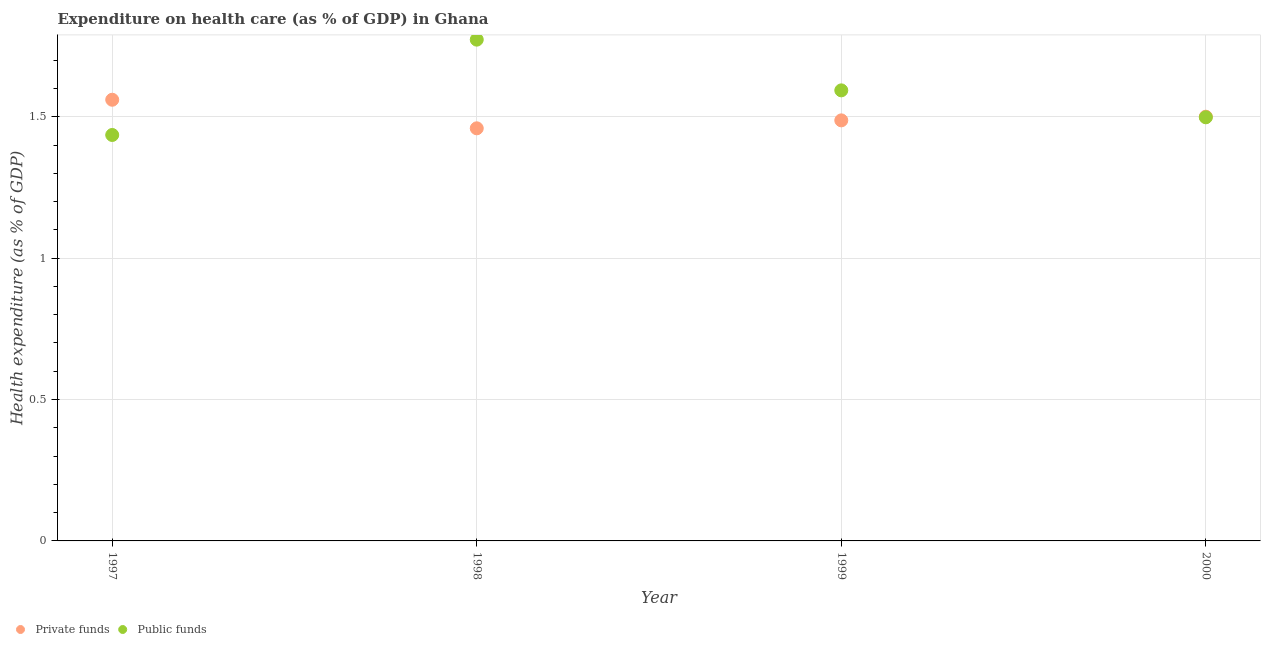What is the amount of private funds spent in healthcare in 2000?
Your answer should be very brief. 1.5. Across all years, what is the maximum amount of public funds spent in healthcare?
Provide a short and direct response. 1.77. Across all years, what is the minimum amount of public funds spent in healthcare?
Your response must be concise. 1.44. In which year was the amount of public funds spent in healthcare maximum?
Your answer should be compact. 1998. In which year was the amount of private funds spent in healthcare minimum?
Your response must be concise. 1998. What is the total amount of public funds spent in healthcare in the graph?
Provide a succinct answer. 6.3. What is the difference between the amount of public funds spent in healthcare in 1997 and that in 1999?
Give a very brief answer. -0.16. What is the difference between the amount of private funds spent in healthcare in 1998 and the amount of public funds spent in healthcare in 2000?
Offer a terse response. -0.04. What is the average amount of private funds spent in healthcare per year?
Offer a very short reply. 1.5. In the year 1998, what is the difference between the amount of private funds spent in healthcare and amount of public funds spent in healthcare?
Keep it short and to the point. -0.31. In how many years, is the amount of public funds spent in healthcare greater than 1.5 %?
Your response must be concise. 2. What is the ratio of the amount of public funds spent in healthcare in 1997 to that in 2000?
Make the answer very short. 0.96. What is the difference between the highest and the second highest amount of private funds spent in healthcare?
Offer a terse response. 0.06. What is the difference between the highest and the lowest amount of private funds spent in healthcare?
Your answer should be compact. 0.1. Is the sum of the amount of public funds spent in healthcare in 1997 and 2000 greater than the maximum amount of private funds spent in healthcare across all years?
Keep it short and to the point. Yes. Does the amount of public funds spent in healthcare monotonically increase over the years?
Make the answer very short. No. Is the amount of private funds spent in healthcare strictly greater than the amount of public funds spent in healthcare over the years?
Your answer should be compact. No. How many dotlines are there?
Ensure brevity in your answer.  2. How many years are there in the graph?
Your answer should be compact. 4. Where does the legend appear in the graph?
Offer a terse response. Bottom left. How are the legend labels stacked?
Offer a terse response. Horizontal. What is the title of the graph?
Keep it short and to the point. Expenditure on health care (as % of GDP) in Ghana. Does "Working only" appear as one of the legend labels in the graph?
Your response must be concise. No. What is the label or title of the X-axis?
Keep it short and to the point. Year. What is the label or title of the Y-axis?
Make the answer very short. Health expenditure (as % of GDP). What is the Health expenditure (as % of GDP) of Private funds in 1997?
Your answer should be very brief. 1.56. What is the Health expenditure (as % of GDP) in Public funds in 1997?
Ensure brevity in your answer.  1.44. What is the Health expenditure (as % of GDP) of Private funds in 1998?
Provide a short and direct response. 1.46. What is the Health expenditure (as % of GDP) of Public funds in 1998?
Your response must be concise. 1.77. What is the Health expenditure (as % of GDP) of Private funds in 1999?
Offer a very short reply. 1.49. What is the Health expenditure (as % of GDP) of Public funds in 1999?
Offer a terse response. 1.59. What is the Health expenditure (as % of GDP) of Private funds in 2000?
Offer a terse response. 1.5. What is the Health expenditure (as % of GDP) of Public funds in 2000?
Offer a terse response. 1.5. Across all years, what is the maximum Health expenditure (as % of GDP) in Private funds?
Provide a short and direct response. 1.56. Across all years, what is the maximum Health expenditure (as % of GDP) of Public funds?
Make the answer very short. 1.77. Across all years, what is the minimum Health expenditure (as % of GDP) in Private funds?
Keep it short and to the point. 1.46. Across all years, what is the minimum Health expenditure (as % of GDP) of Public funds?
Offer a terse response. 1.44. What is the total Health expenditure (as % of GDP) in Private funds in the graph?
Make the answer very short. 6.01. What is the total Health expenditure (as % of GDP) in Public funds in the graph?
Ensure brevity in your answer.  6.3. What is the difference between the Health expenditure (as % of GDP) in Private funds in 1997 and that in 1998?
Provide a short and direct response. 0.1. What is the difference between the Health expenditure (as % of GDP) in Public funds in 1997 and that in 1998?
Offer a terse response. -0.34. What is the difference between the Health expenditure (as % of GDP) in Private funds in 1997 and that in 1999?
Offer a terse response. 0.07. What is the difference between the Health expenditure (as % of GDP) of Public funds in 1997 and that in 1999?
Offer a very short reply. -0.16. What is the difference between the Health expenditure (as % of GDP) of Private funds in 1997 and that in 2000?
Keep it short and to the point. 0.06. What is the difference between the Health expenditure (as % of GDP) in Public funds in 1997 and that in 2000?
Provide a succinct answer. -0.06. What is the difference between the Health expenditure (as % of GDP) of Private funds in 1998 and that in 1999?
Your response must be concise. -0.03. What is the difference between the Health expenditure (as % of GDP) of Public funds in 1998 and that in 1999?
Your response must be concise. 0.18. What is the difference between the Health expenditure (as % of GDP) in Private funds in 1998 and that in 2000?
Make the answer very short. -0.04. What is the difference between the Health expenditure (as % of GDP) of Public funds in 1998 and that in 2000?
Offer a terse response. 0.27. What is the difference between the Health expenditure (as % of GDP) in Private funds in 1999 and that in 2000?
Offer a terse response. -0.01. What is the difference between the Health expenditure (as % of GDP) of Public funds in 1999 and that in 2000?
Your response must be concise. 0.1. What is the difference between the Health expenditure (as % of GDP) of Private funds in 1997 and the Health expenditure (as % of GDP) of Public funds in 1998?
Make the answer very short. -0.21. What is the difference between the Health expenditure (as % of GDP) in Private funds in 1997 and the Health expenditure (as % of GDP) in Public funds in 1999?
Ensure brevity in your answer.  -0.03. What is the difference between the Health expenditure (as % of GDP) in Private funds in 1997 and the Health expenditure (as % of GDP) in Public funds in 2000?
Give a very brief answer. 0.06. What is the difference between the Health expenditure (as % of GDP) of Private funds in 1998 and the Health expenditure (as % of GDP) of Public funds in 1999?
Provide a short and direct response. -0.13. What is the difference between the Health expenditure (as % of GDP) in Private funds in 1998 and the Health expenditure (as % of GDP) in Public funds in 2000?
Ensure brevity in your answer.  -0.04. What is the difference between the Health expenditure (as % of GDP) in Private funds in 1999 and the Health expenditure (as % of GDP) in Public funds in 2000?
Provide a short and direct response. -0.01. What is the average Health expenditure (as % of GDP) in Private funds per year?
Keep it short and to the point. 1.5. What is the average Health expenditure (as % of GDP) in Public funds per year?
Your answer should be compact. 1.57. In the year 1997, what is the difference between the Health expenditure (as % of GDP) of Private funds and Health expenditure (as % of GDP) of Public funds?
Your response must be concise. 0.12. In the year 1998, what is the difference between the Health expenditure (as % of GDP) in Private funds and Health expenditure (as % of GDP) in Public funds?
Offer a very short reply. -0.31. In the year 1999, what is the difference between the Health expenditure (as % of GDP) of Private funds and Health expenditure (as % of GDP) of Public funds?
Ensure brevity in your answer.  -0.11. In the year 2000, what is the difference between the Health expenditure (as % of GDP) in Private funds and Health expenditure (as % of GDP) in Public funds?
Keep it short and to the point. 0. What is the ratio of the Health expenditure (as % of GDP) of Private funds in 1997 to that in 1998?
Keep it short and to the point. 1.07. What is the ratio of the Health expenditure (as % of GDP) in Public funds in 1997 to that in 1998?
Your answer should be compact. 0.81. What is the ratio of the Health expenditure (as % of GDP) in Private funds in 1997 to that in 1999?
Offer a terse response. 1.05. What is the ratio of the Health expenditure (as % of GDP) of Public funds in 1997 to that in 1999?
Give a very brief answer. 0.9. What is the ratio of the Health expenditure (as % of GDP) of Private funds in 1997 to that in 2000?
Provide a succinct answer. 1.04. What is the ratio of the Health expenditure (as % of GDP) of Private funds in 1998 to that in 1999?
Keep it short and to the point. 0.98. What is the ratio of the Health expenditure (as % of GDP) in Public funds in 1998 to that in 1999?
Your answer should be very brief. 1.11. What is the ratio of the Health expenditure (as % of GDP) of Private funds in 1998 to that in 2000?
Offer a very short reply. 0.97. What is the ratio of the Health expenditure (as % of GDP) of Public funds in 1998 to that in 2000?
Provide a succinct answer. 1.18. What is the ratio of the Health expenditure (as % of GDP) of Public funds in 1999 to that in 2000?
Keep it short and to the point. 1.06. What is the difference between the highest and the second highest Health expenditure (as % of GDP) of Private funds?
Your answer should be compact. 0.06. What is the difference between the highest and the second highest Health expenditure (as % of GDP) of Public funds?
Offer a terse response. 0.18. What is the difference between the highest and the lowest Health expenditure (as % of GDP) of Private funds?
Make the answer very short. 0.1. What is the difference between the highest and the lowest Health expenditure (as % of GDP) of Public funds?
Provide a short and direct response. 0.34. 